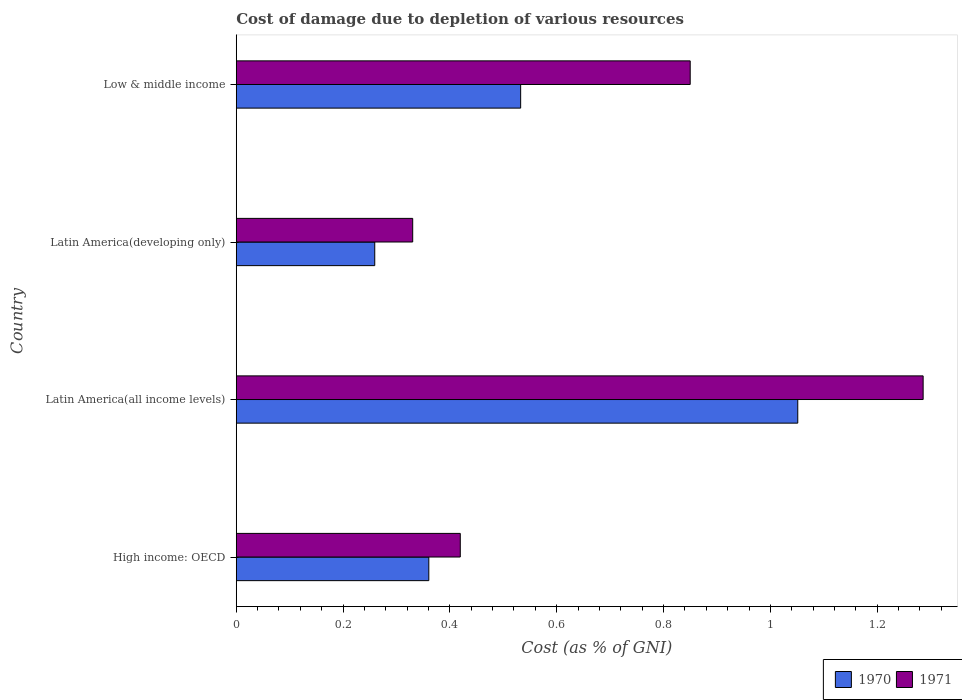How many groups of bars are there?
Provide a short and direct response. 4. What is the label of the 2nd group of bars from the top?
Provide a succinct answer. Latin America(developing only). What is the cost of damage caused due to the depletion of various resources in 1970 in Low & middle income?
Provide a short and direct response. 0.53. Across all countries, what is the maximum cost of damage caused due to the depletion of various resources in 1971?
Offer a terse response. 1.29. Across all countries, what is the minimum cost of damage caused due to the depletion of various resources in 1971?
Make the answer very short. 0.33. In which country was the cost of damage caused due to the depletion of various resources in 1971 maximum?
Your answer should be compact. Latin America(all income levels). In which country was the cost of damage caused due to the depletion of various resources in 1971 minimum?
Your response must be concise. Latin America(developing only). What is the total cost of damage caused due to the depletion of various resources in 1971 in the graph?
Provide a short and direct response. 2.89. What is the difference between the cost of damage caused due to the depletion of various resources in 1970 in High income: OECD and that in Latin America(all income levels)?
Make the answer very short. -0.69. What is the difference between the cost of damage caused due to the depletion of various resources in 1971 in Latin America(all income levels) and the cost of damage caused due to the depletion of various resources in 1970 in Latin America(developing only)?
Provide a succinct answer. 1.03. What is the average cost of damage caused due to the depletion of various resources in 1971 per country?
Your response must be concise. 0.72. What is the difference between the cost of damage caused due to the depletion of various resources in 1970 and cost of damage caused due to the depletion of various resources in 1971 in High income: OECD?
Offer a terse response. -0.06. In how many countries, is the cost of damage caused due to the depletion of various resources in 1970 greater than 0.04 %?
Give a very brief answer. 4. What is the ratio of the cost of damage caused due to the depletion of various resources in 1970 in Latin America(developing only) to that in Low & middle income?
Your answer should be very brief. 0.49. Is the cost of damage caused due to the depletion of various resources in 1971 in Latin America(all income levels) less than that in Low & middle income?
Make the answer very short. No. What is the difference between the highest and the second highest cost of damage caused due to the depletion of various resources in 1970?
Ensure brevity in your answer.  0.52. What is the difference between the highest and the lowest cost of damage caused due to the depletion of various resources in 1971?
Give a very brief answer. 0.96. How many countries are there in the graph?
Offer a very short reply. 4. Are the values on the major ticks of X-axis written in scientific E-notation?
Give a very brief answer. No. Does the graph contain grids?
Provide a succinct answer. No. Where does the legend appear in the graph?
Your response must be concise. Bottom right. How many legend labels are there?
Provide a succinct answer. 2. How are the legend labels stacked?
Your answer should be compact. Horizontal. What is the title of the graph?
Provide a short and direct response. Cost of damage due to depletion of various resources. What is the label or title of the X-axis?
Offer a terse response. Cost (as % of GNI). What is the label or title of the Y-axis?
Keep it short and to the point. Country. What is the Cost (as % of GNI) of 1970 in High income: OECD?
Your answer should be compact. 0.36. What is the Cost (as % of GNI) in 1971 in High income: OECD?
Offer a very short reply. 0.42. What is the Cost (as % of GNI) of 1970 in Latin America(all income levels)?
Provide a short and direct response. 1.05. What is the Cost (as % of GNI) of 1971 in Latin America(all income levels)?
Ensure brevity in your answer.  1.29. What is the Cost (as % of GNI) in 1970 in Latin America(developing only)?
Ensure brevity in your answer.  0.26. What is the Cost (as % of GNI) of 1971 in Latin America(developing only)?
Your answer should be very brief. 0.33. What is the Cost (as % of GNI) of 1970 in Low & middle income?
Make the answer very short. 0.53. What is the Cost (as % of GNI) of 1971 in Low & middle income?
Give a very brief answer. 0.85. Across all countries, what is the maximum Cost (as % of GNI) of 1970?
Provide a short and direct response. 1.05. Across all countries, what is the maximum Cost (as % of GNI) in 1971?
Keep it short and to the point. 1.29. Across all countries, what is the minimum Cost (as % of GNI) in 1970?
Offer a very short reply. 0.26. Across all countries, what is the minimum Cost (as % of GNI) of 1971?
Give a very brief answer. 0.33. What is the total Cost (as % of GNI) of 1970 in the graph?
Ensure brevity in your answer.  2.2. What is the total Cost (as % of GNI) in 1971 in the graph?
Give a very brief answer. 2.89. What is the difference between the Cost (as % of GNI) in 1970 in High income: OECD and that in Latin America(all income levels)?
Offer a terse response. -0.69. What is the difference between the Cost (as % of GNI) in 1971 in High income: OECD and that in Latin America(all income levels)?
Ensure brevity in your answer.  -0.87. What is the difference between the Cost (as % of GNI) in 1970 in High income: OECD and that in Latin America(developing only)?
Your answer should be very brief. 0.1. What is the difference between the Cost (as % of GNI) of 1971 in High income: OECD and that in Latin America(developing only)?
Give a very brief answer. 0.09. What is the difference between the Cost (as % of GNI) in 1970 in High income: OECD and that in Low & middle income?
Keep it short and to the point. -0.17. What is the difference between the Cost (as % of GNI) in 1971 in High income: OECD and that in Low & middle income?
Ensure brevity in your answer.  -0.43. What is the difference between the Cost (as % of GNI) of 1970 in Latin America(all income levels) and that in Latin America(developing only)?
Ensure brevity in your answer.  0.79. What is the difference between the Cost (as % of GNI) of 1971 in Latin America(all income levels) and that in Latin America(developing only)?
Provide a succinct answer. 0.96. What is the difference between the Cost (as % of GNI) in 1970 in Latin America(all income levels) and that in Low & middle income?
Offer a very short reply. 0.52. What is the difference between the Cost (as % of GNI) in 1971 in Latin America(all income levels) and that in Low & middle income?
Keep it short and to the point. 0.44. What is the difference between the Cost (as % of GNI) of 1970 in Latin America(developing only) and that in Low & middle income?
Provide a succinct answer. -0.27. What is the difference between the Cost (as % of GNI) of 1971 in Latin America(developing only) and that in Low & middle income?
Ensure brevity in your answer.  -0.52. What is the difference between the Cost (as % of GNI) in 1970 in High income: OECD and the Cost (as % of GNI) in 1971 in Latin America(all income levels)?
Give a very brief answer. -0.93. What is the difference between the Cost (as % of GNI) in 1970 in High income: OECD and the Cost (as % of GNI) in 1971 in Latin America(developing only)?
Give a very brief answer. 0.03. What is the difference between the Cost (as % of GNI) of 1970 in High income: OECD and the Cost (as % of GNI) of 1971 in Low & middle income?
Your response must be concise. -0.49. What is the difference between the Cost (as % of GNI) of 1970 in Latin America(all income levels) and the Cost (as % of GNI) of 1971 in Latin America(developing only)?
Provide a short and direct response. 0.72. What is the difference between the Cost (as % of GNI) in 1970 in Latin America(all income levels) and the Cost (as % of GNI) in 1971 in Low & middle income?
Offer a very short reply. 0.2. What is the difference between the Cost (as % of GNI) of 1970 in Latin America(developing only) and the Cost (as % of GNI) of 1971 in Low & middle income?
Provide a succinct answer. -0.59. What is the average Cost (as % of GNI) of 1970 per country?
Keep it short and to the point. 0.55. What is the average Cost (as % of GNI) of 1971 per country?
Ensure brevity in your answer.  0.72. What is the difference between the Cost (as % of GNI) in 1970 and Cost (as % of GNI) in 1971 in High income: OECD?
Your response must be concise. -0.06. What is the difference between the Cost (as % of GNI) in 1970 and Cost (as % of GNI) in 1971 in Latin America(all income levels)?
Provide a succinct answer. -0.23. What is the difference between the Cost (as % of GNI) in 1970 and Cost (as % of GNI) in 1971 in Latin America(developing only)?
Offer a terse response. -0.07. What is the difference between the Cost (as % of GNI) in 1970 and Cost (as % of GNI) in 1971 in Low & middle income?
Provide a succinct answer. -0.32. What is the ratio of the Cost (as % of GNI) in 1970 in High income: OECD to that in Latin America(all income levels)?
Keep it short and to the point. 0.34. What is the ratio of the Cost (as % of GNI) in 1971 in High income: OECD to that in Latin America(all income levels)?
Your answer should be very brief. 0.33. What is the ratio of the Cost (as % of GNI) of 1970 in High income: OECD to that in Latin America(developing only)?
Make the answer very short. 1.39. What is the ratio of the Cost (as % of GNI) in 1971 in High income: OECD to that in Latin America(developing only)?
Ensure brevity in your answer.  1.27. What is the ratio of the Cost (as % of GNI) of 1970 in High income: OECD to that in Low & middle income?
Keep it short and to the point. 0.68. What is the ratio of the Cost (as % of GNI) of 1971 in High income: OECD to that in Low & middle income?
Make the answer very short. 0.49. What is the ratio of the Cost (as % of GNI) of 1970 in Latin America(all income levels) to that in Latin America(developing only)?
Your answer should be very brief. 4.05. What is the ratio of the Cost (as % of GNI) of 1971 in Latin America(all income levels) to that in Latin America(developing only)?
Your answer should be very brief. 3.89. What is the ratio of the Cost (as % of GNI) of 1970 in Latin America(all income levels) to that in Low & middle income?
Ensure brevity in your answer.  1.97. What is the ratio of the Cost (as % of GNI) of 1971 in Latin America(all income levels) to that in Low & middle income?
Your answer should be very brief. 1.51. What is the ratio of the Cost (as % of GNI) in 1970 in Latin America(developing only) to that in Low & middle income?
Your answer should be very brief. 0.49. What is the ratio of the Cost (as % of GNI) of 1971 in Latin America(developing only) to that in Low & middle income?
Offer a very short reply. 0.39. What is the difference between the highest and the second highest Cost (as % of GNI) of 1970?
Your response must be concise. 0.52. What is the difference between the highest and the second highest Cost (as % of GNI) of 1971?
Offer a very short reply. 0.44. What is the difference between the highest and the lowest Cost (as % of GNI) in 1970?
Your answer should be compact. 0.79. What is the difference between the highest and the lowest Cost (as % of GNI) of 1971?
Your response must be concise. 0.96. 